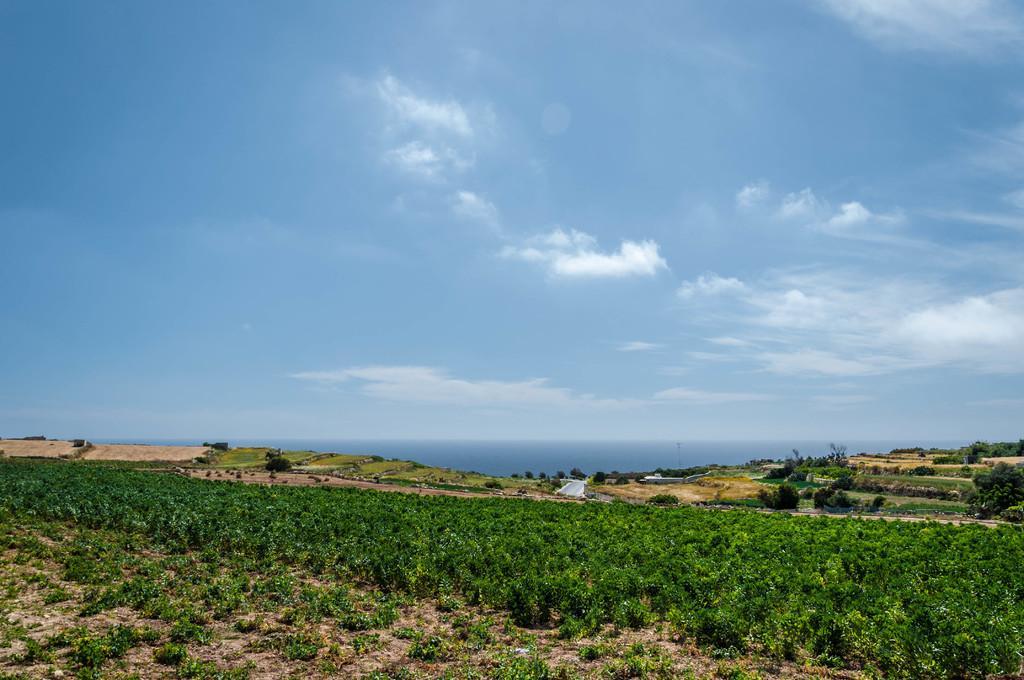Please provide a concise description of this image. Front of the image we can see plants. In the background we can see grass,trees and sky with clouds. 